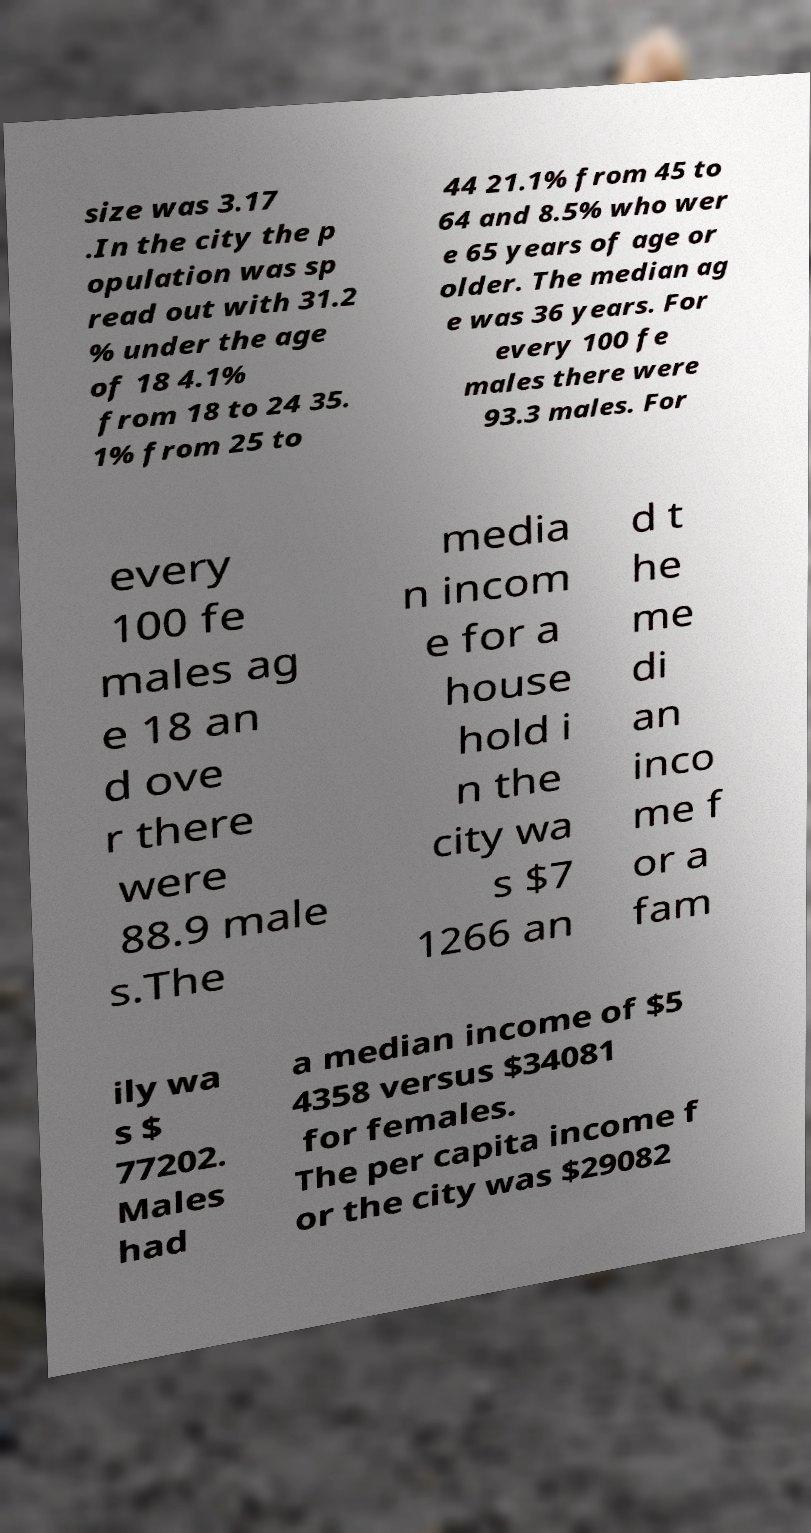Could you assist in decoding the text presented in this image and type it out clearly? size was 3.17 .In the city the p opulation was sp read out with 31.2 % under the age of 18 4.1% from 18 to 24 35. 1% from 25 to 44 21.1% from 45 to 64 and 8.5% who wer e 65 years of age or older. The median ag e was 36 years. For every 100 fe males there were 93.3 males. For every 100 fe males ag e 18 an d ove r there were 88.9 male s.The media n incom e for a house hold i n the city wa s $7 1266 an d t he me di an inco me f or a fam ily wa s $ 77202. Males had a median income of $5 4358 versus $34081 for females. The per capita income f or the city was $29082 